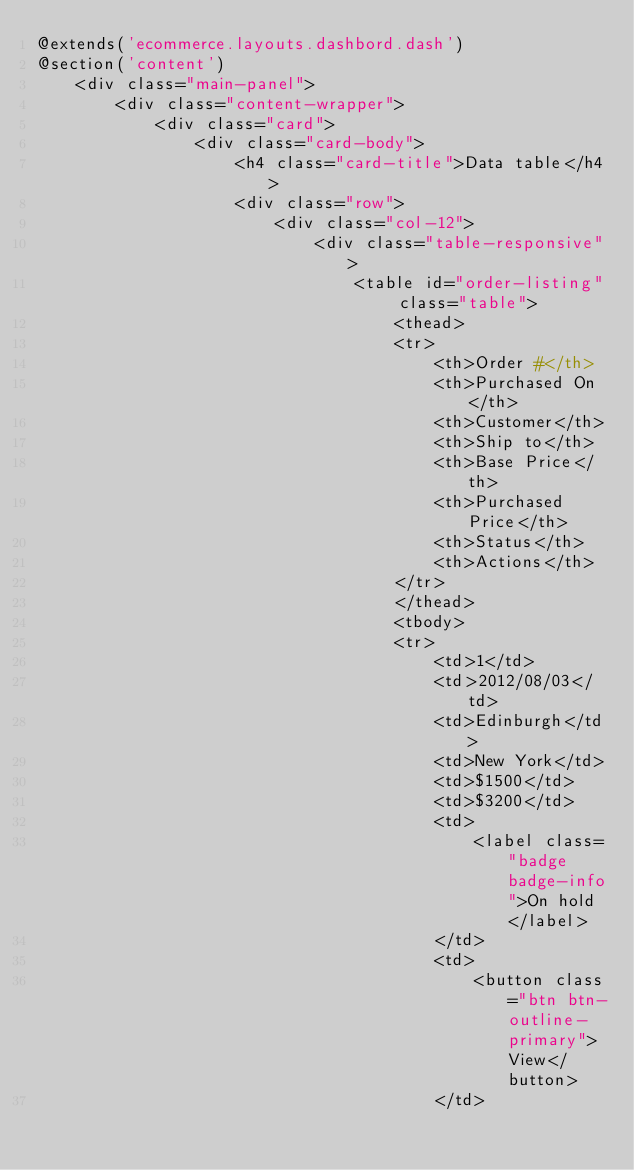Convert code to text. <code><loc_0><loc_0><loc_500><loc_500><_PHP_>@extends('ecommerce.layouts.dashbord.dash')
@section('content')
    <div class="main-panel">
        <div class="content-wrapper">
            <div class="card">
                <div class="card-body">
                    <h4 class="card-title">Data table</h4>
                    <div class="row">
                        <div class="col-12">
                            <div class="table-responsive">
                                <table id="order-listing" class="table">
                                    <thead>
                                    <tr>
                                        <th>Order #</th>
                                        <th>Purchased On</th>
                                        <th>Customer</th>
                                        <th>Ship to</th>
                                        <th>Base Price</th>
                                        <th>Purchased Price</th>
                                        <th>Status</th>
                                        <th>Actions</th>
                                    </tr>
                                    </thead>
                                    <tbody>
                                    <tr>
                                        <td>1</td>
                                        <td>2012/08/03</td>
                                        <td>Edinburgh</td>
                                        <td>New York</td>
                                        <td>$1500</td>
                                        <td>$3200</td>
                                        <td>
                                            <label class="badge badge-info">On hold</label>
                                        </td>
                                        <td>
                                            <button class="btn btn-outline-primary">View</button>
                                        </td></code> 